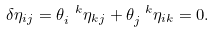Convert formula to latex. <formula><loc_0><loc_0><loc_500><loc_500>\delta \eta _ { i j } = \theta _ { i } ^ { \ k } \eta _ { k j } + \theta _ { j } ^ { \ k } \eta _ { i k } = 0 .</formula> 